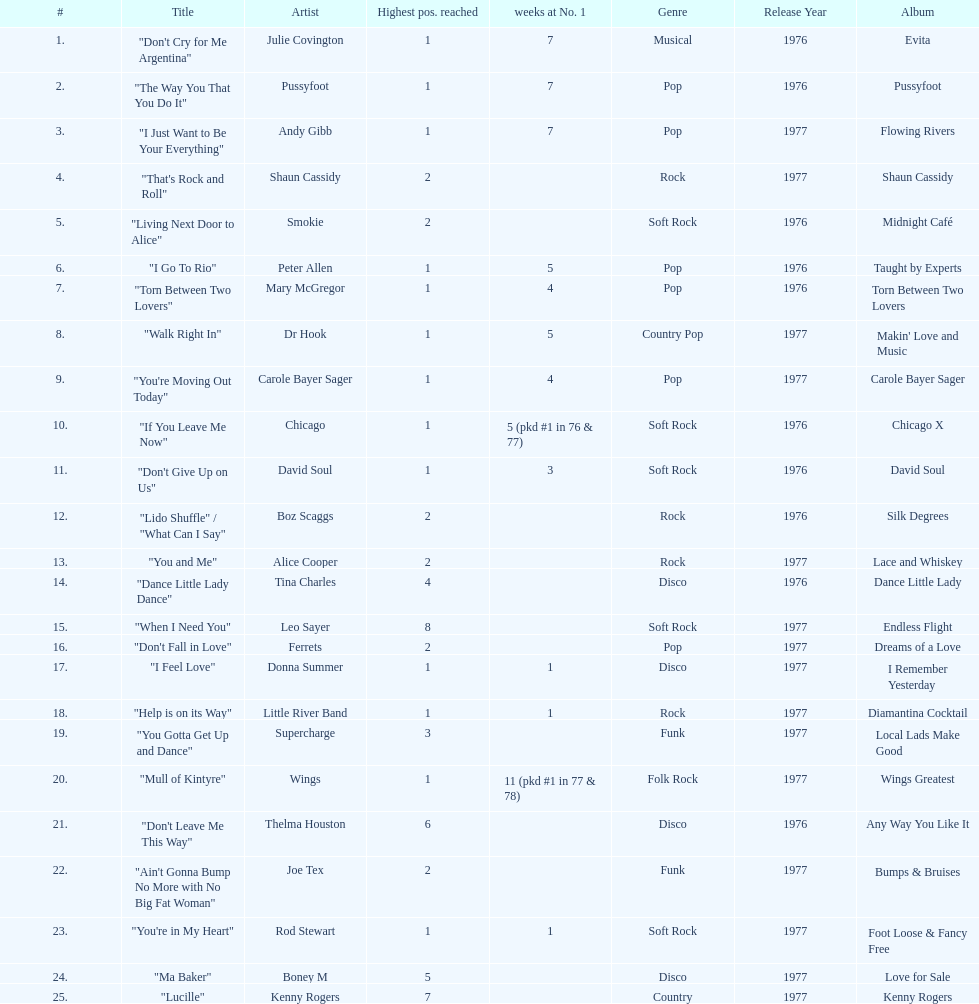Which three artists had a single at number 1 for at least 7 weeks on the australian singles charts in 1977? Julie Covington, Pussyfoot, Andy Gibb. 